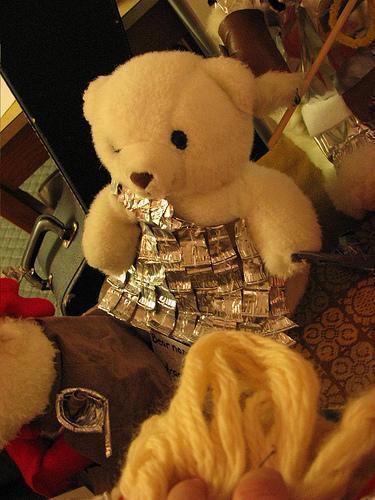How many teddy bears are in the photo?
Give a very brief answer. 1. 